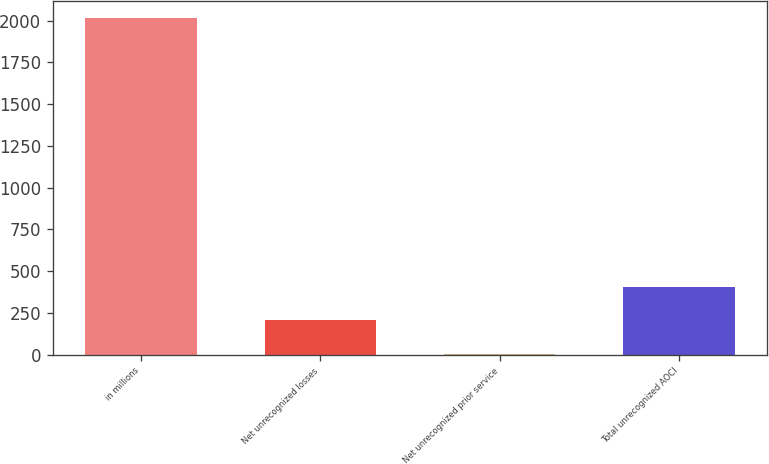<chart> <loc_0><loc_0><loc_500><loc_500><bar_chart><fcel>in millions<fcel>Net unrecognized losses<fcel>Net unrecognized prior service<fcel>Total unrecognized AOCI<nl><fcel>2015<fcel>204.2<fcel>3<fcel>405.4<nl></chart> 